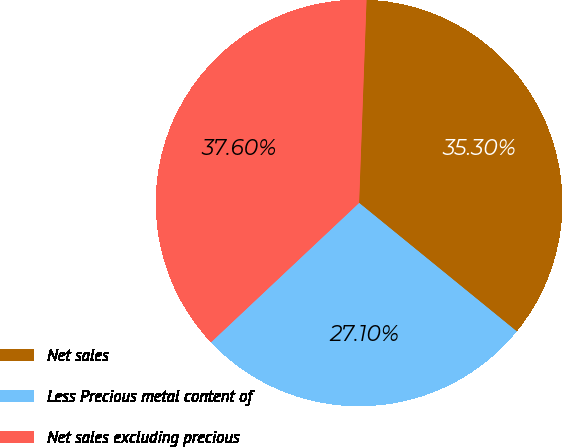<chart> <loc_0><loc_0><loc_500><loc_500><pie_chart><fcel>Net sales<fcel>Less Precious metal content of<fcel>Net sales excluding precious<nl><fcel>35.3%<fcel>27.1%<fcel>37.6%<nl></chart> 